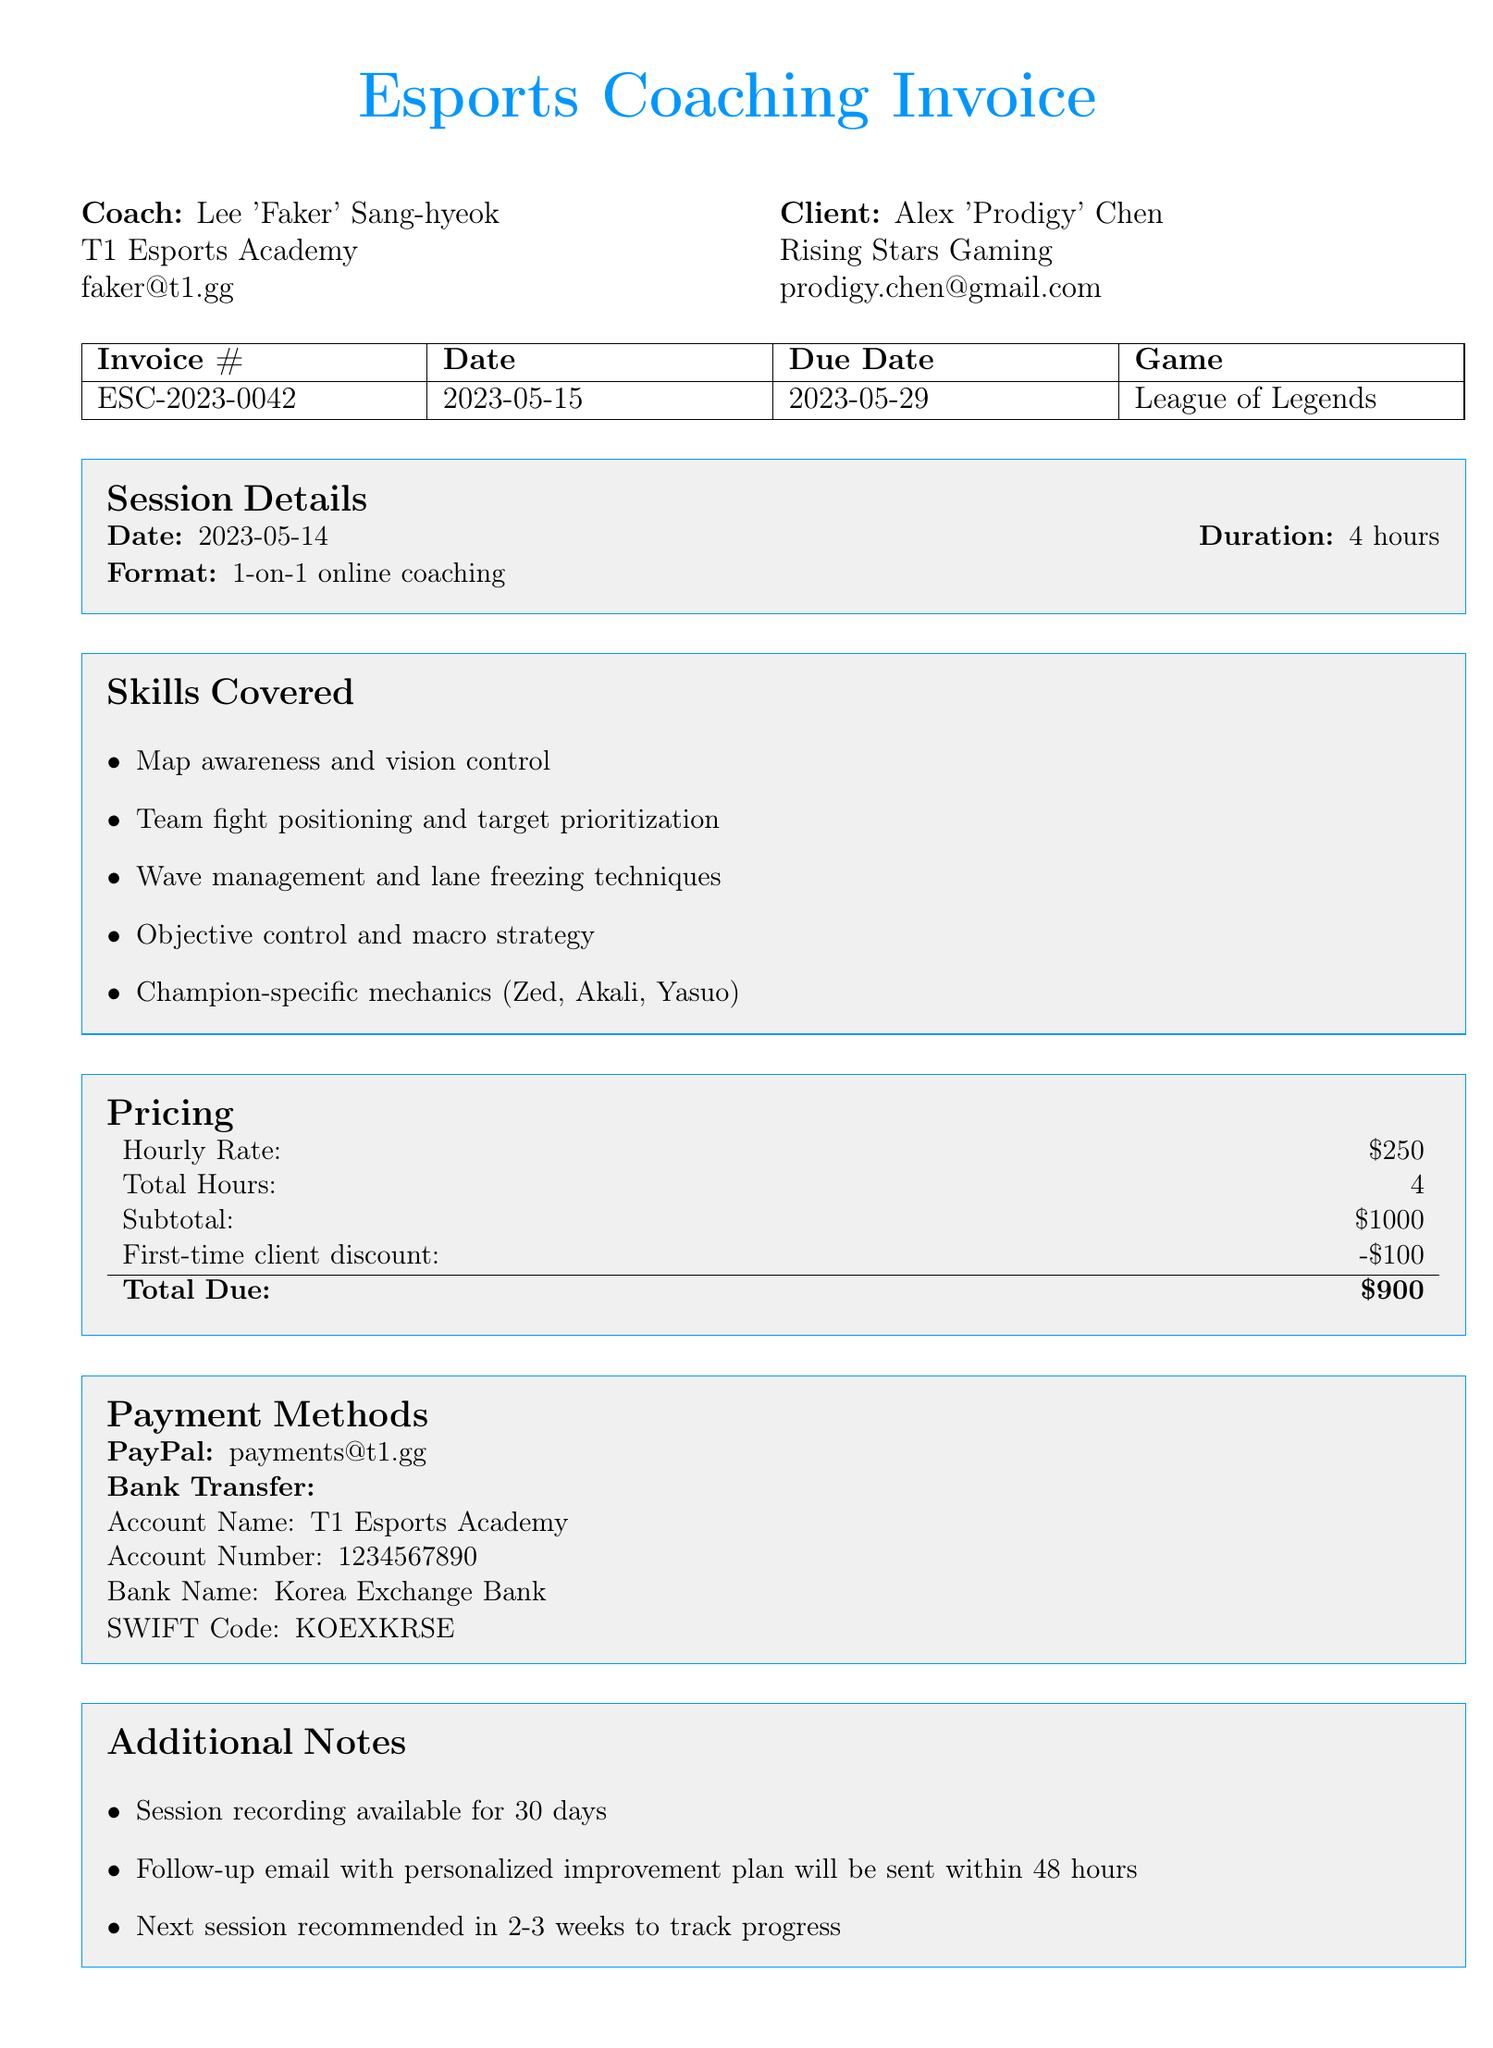What is the invoice number? The invoice number is a unique identifier for this transaction, specifically stated in the document.
Answer: ESC-2023-0042 Who is the coach? The coach's name is prominently listed in the document details.
Answer: Lee 'Faker' Sang-hyeok What is the duration of the coaching session? The duration indicates how long the session took place, as specified in the session details.
Answer: 4 hours What is the total amount due? The total amount due is the final charge after any discounts, calculated in the pricing section.
Answer: $900 What specific skills were covered during the session? The skills covered are listed in a bullet point format and detail the specific areas of focus.
Answer: Map awareness and vision control When was the coaching session conducted? The date of the session is listed under the session details in the document.
Answer: 2023-05-14 What is the first-time client discount amount? The discount amount is provided under the pricing section specifically for new clients.
Answer: $100 Which payment method requires an account number? The payment methods section specifies which method requires additional bank details.
Answer: Bank Transfer What is stated about session recordings? The document mentions specific conditions regarding session recordings available to clients.
Answer: Session recording available for 30 days 